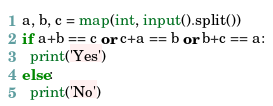<code> <loc_0><loc_0><loc_500><loc_500><_Python_>a, b, c = map(int, input().split())
if a+b == c or c+a == b or b+c == a:
  print('Yes')
else:
  print('No')</code> 